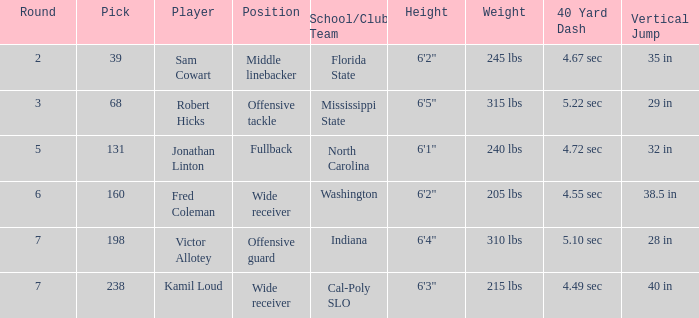Which Round has a School/Club Team of north carolina, and a Pick larger than 131? 0.0. 